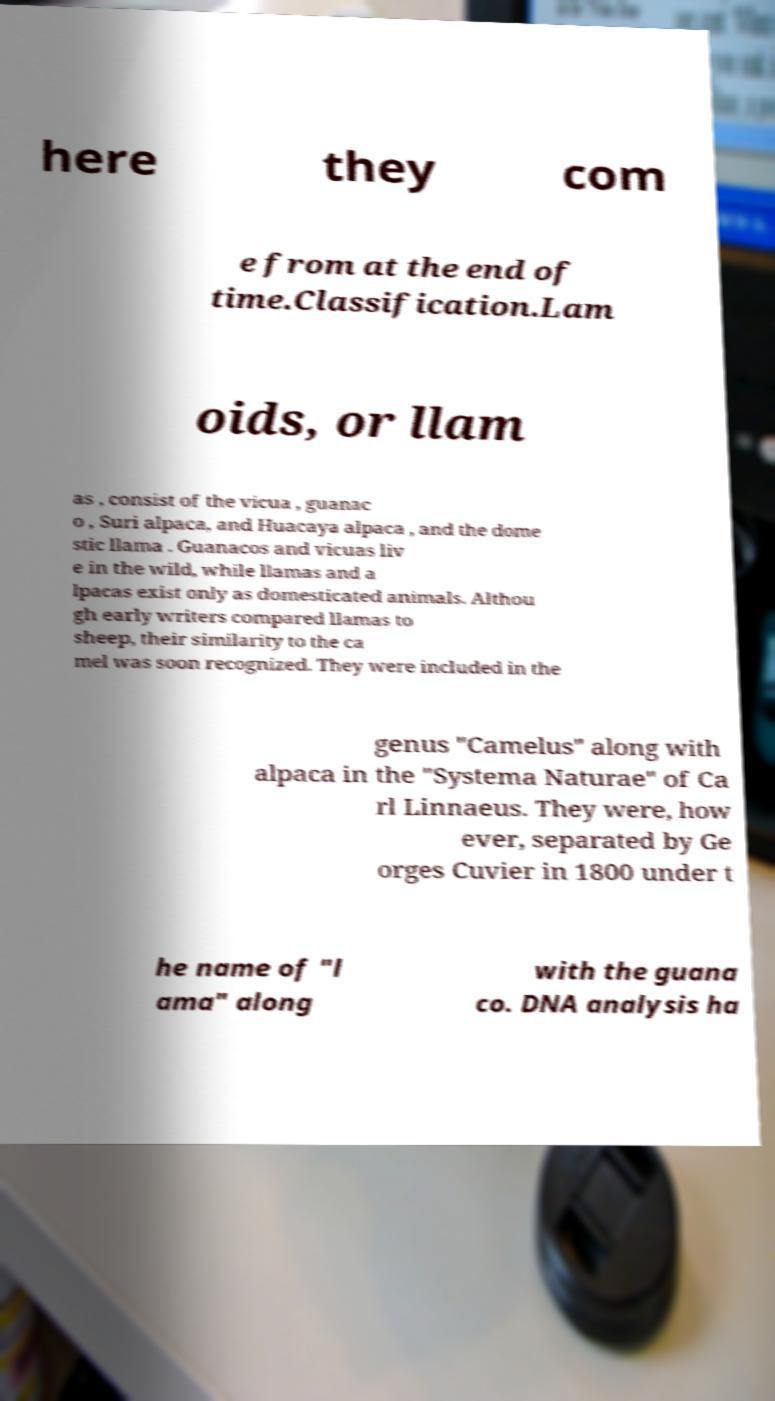Could you extract and type out the text from this image? here they com e from at the end of time.Classification.Lam oids, or llam as , consist of the vicua , guanac o , Suri alpaca, and Huacaya alpaca , and the dome stic llama . Guanacos and vicuas liv e in the wild, while llamas and a lpacas exist only as domesticated animals. Althou gh early writers compared llamas to sheep, their similarity to the ca mel was soon recognized. They were included in the genus "Camelus" along with alpaca in the "Systema Naturae" of Ca rl Linnaeus. They were, how ever, separated by Ge orges Cuvier in 1800 under t he name of "l ama" along with the guana co. DNA analysis ha 